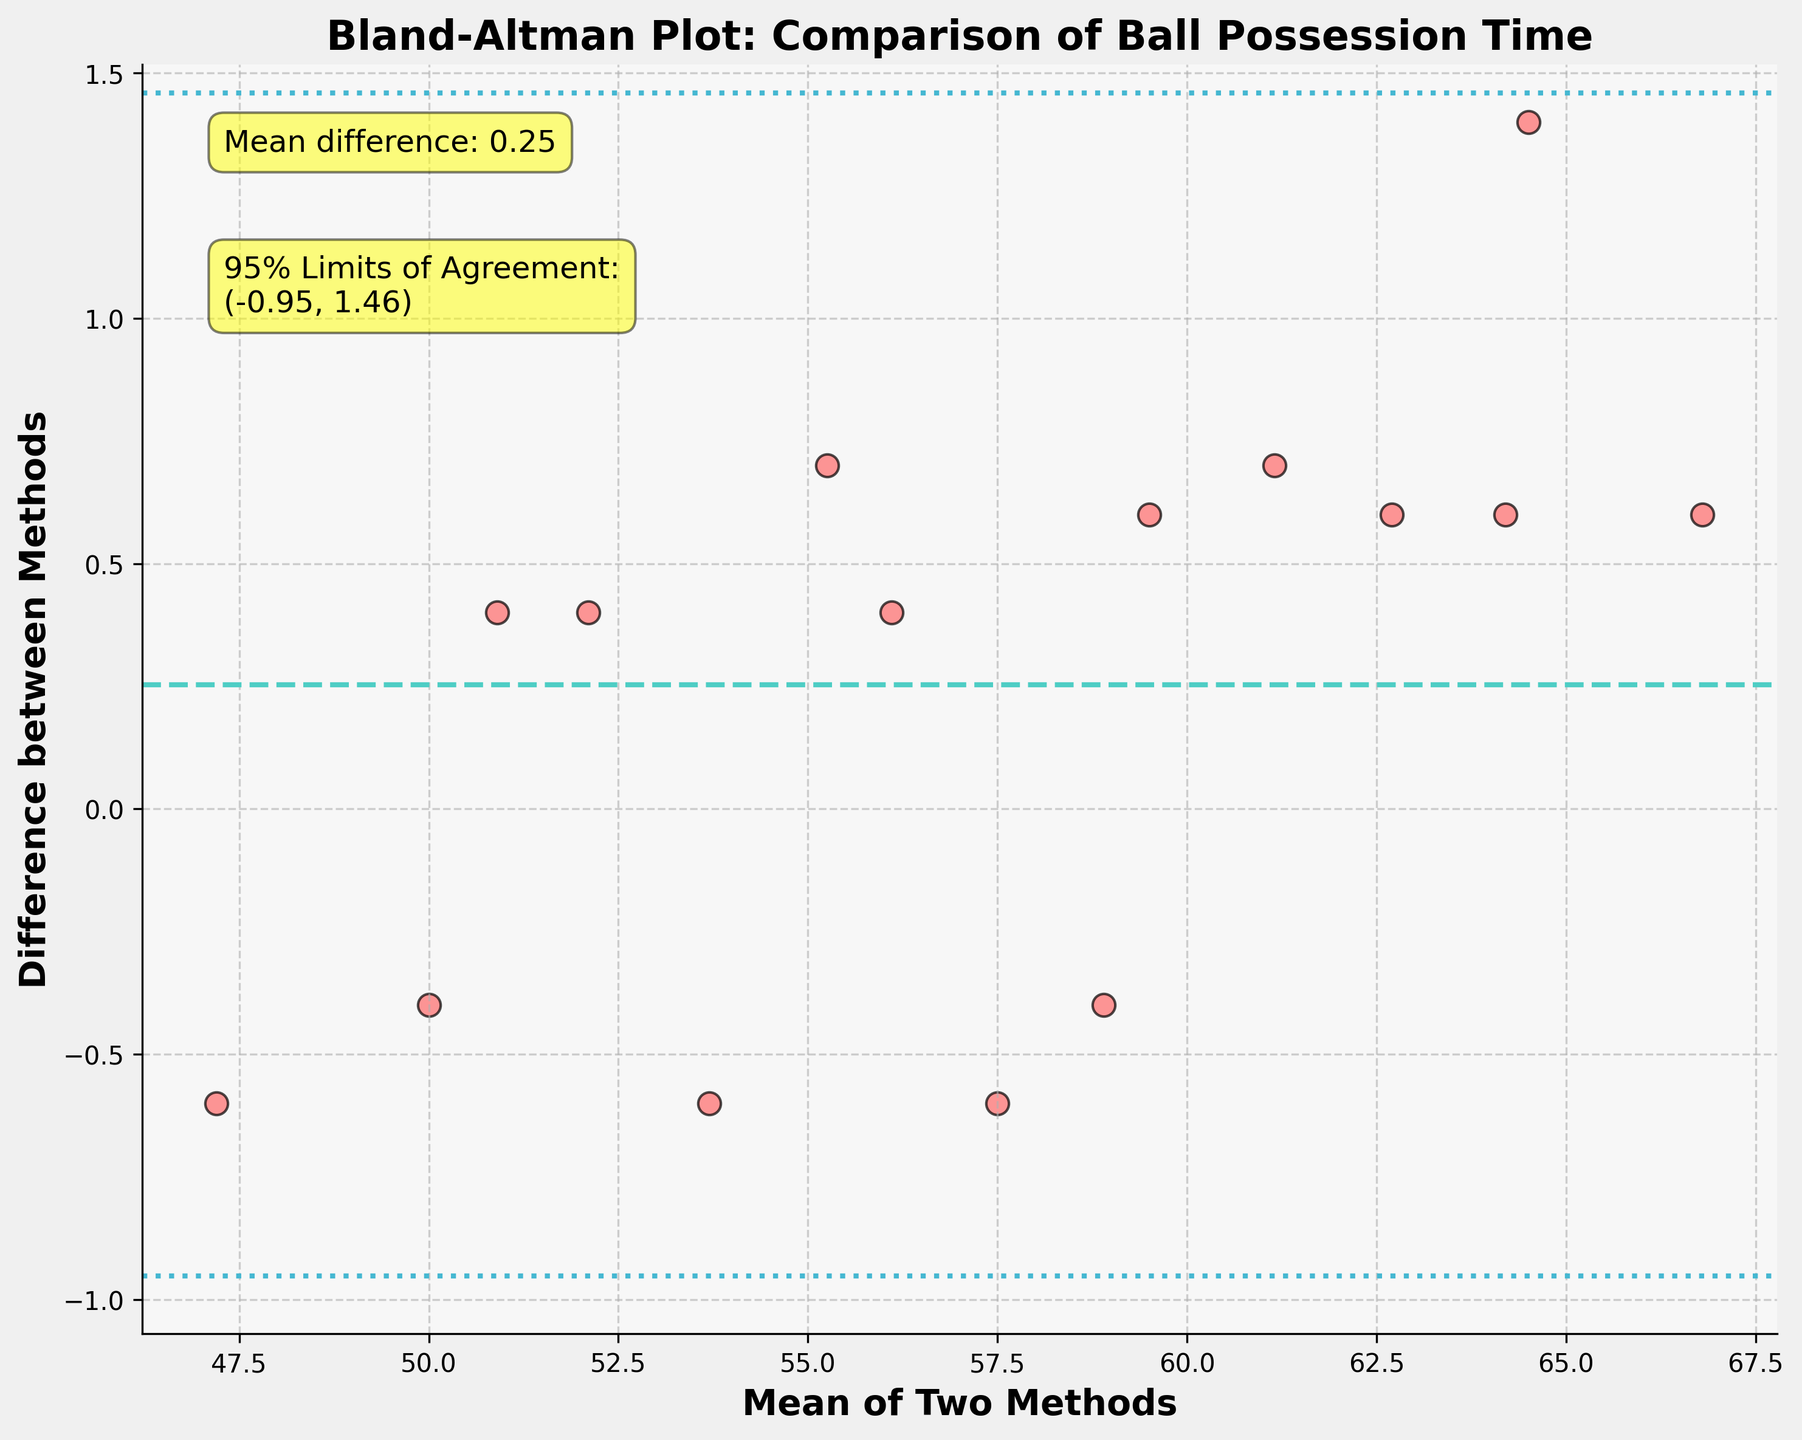What is the title of the figure? The title is located at the top of the figure and usually gives a summary of what the plot represents. In this case, it specifies the context: ball possession time comparison in football matches using Bland-Altman analysis.
Answer: Bland-Altman Plot: Comparison of Ball Possession Time How many data points are plotted on the graph? By counting the individual points in the scatter plot, we can determine the number of data points. Each plotted point corresponds to a pair of measurements from Methods A and B.
Answer: 15 What is the mean difference between the two methods? The mean difference is shown by a horizontal line in the plot, and it’s also annotated as a text box in the figure. This value represents the average of the differences between the two methods.
Answer: 0.27 What are the 95% limits of agreement for the differences between the two methods? The limits of agreement are typically shown as two horizontal lines above and below the mean difference line. They are also annotated in the figure. These values represent the range within which 95% of the differences between the two methods fall.
Answer: (-0.85, 1.39) Is there a general trend in the differences as the mean value increases? To assess this, look at how the points are scattered relative to the mean. If the differences tend to increase or decrease as the mean increases, there is a trend.
Answer: No clear trend Which two data points have the largest positive and negative differences, respectively? Identify the highest and lowest points on the y-axis (difference) to find these data points. The largest positive difference is the highest point above the mean difference, and the largest negative difference is the lowest point below the mean difference.
Answer: Largest positive: 1.4; Largest negative: -0.6 Do more data points lie above or below the mean difference? Count the number of points above and below the mean difference line, which is marked by a dashed line on the plot. This helps to understand whether there is a bias in one direction.
Answer: Below What does being within the 95% limits of agreement indicate about the two methods? The provided limits of agreement indicate the range of differences expected for 95% of the data. If most points lie within these limits, it suggests good agreement between the two methods.
Answer: Good agreement Which is the first data point on the plot, and what are its coordinates? The first data point can be identified by its coordinates based on the order of data. The x-coordinate (mean of the two methods) and y-coordinate (difference between the methods) describe its position.
Answer: (64.5, 1.4) Is there any data point exactly at the mean difference? Check if any point on the scatter plot lies directly on the horizontal line that represents the mean difference. This can indicate perfect agreement for that pair of observations.
Answer: No 